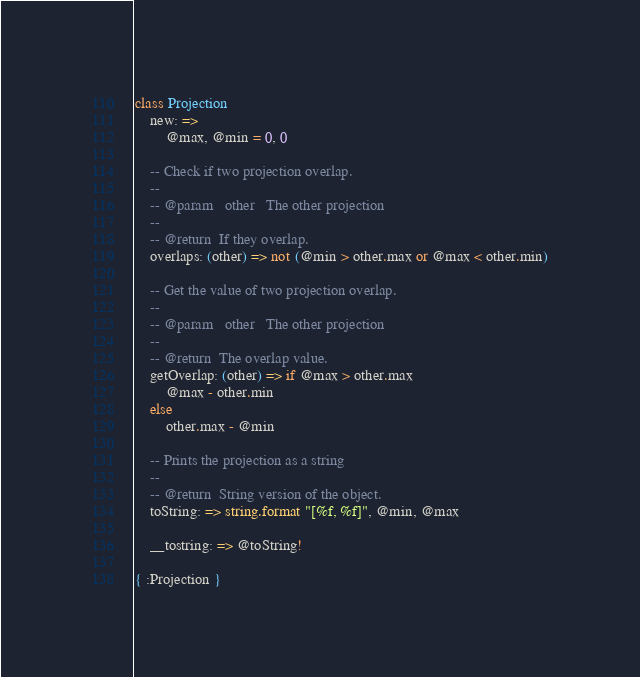Convert code to text. <code><loc_0><loc_0><loc_500><loc_500><_MoonScript_>class Projection
	new: =>
		@max, @min = 0, 0

	-- Check if two projection overlap.
	--
	-- @param	other	The other projection
	--
	-- @return	If they overlap.
	overlaps: (other) => not (@min > other.max or @max < other.min)

	-- Get the value of two projection overlap.
	--
	-- @param	other	The other projection
	--
	-- @return	The overlap value.
	getOverlap: (other) => if @max > other.max
		@max - other.min
	else
		other.max - @min

	-- Prints the projection as a string
	--
	-- @return	String version of the object.
	toString: => string.format "[%f, %f]", @min, @max

	__tostring: => @toString!

{ :Projection }
</code> 